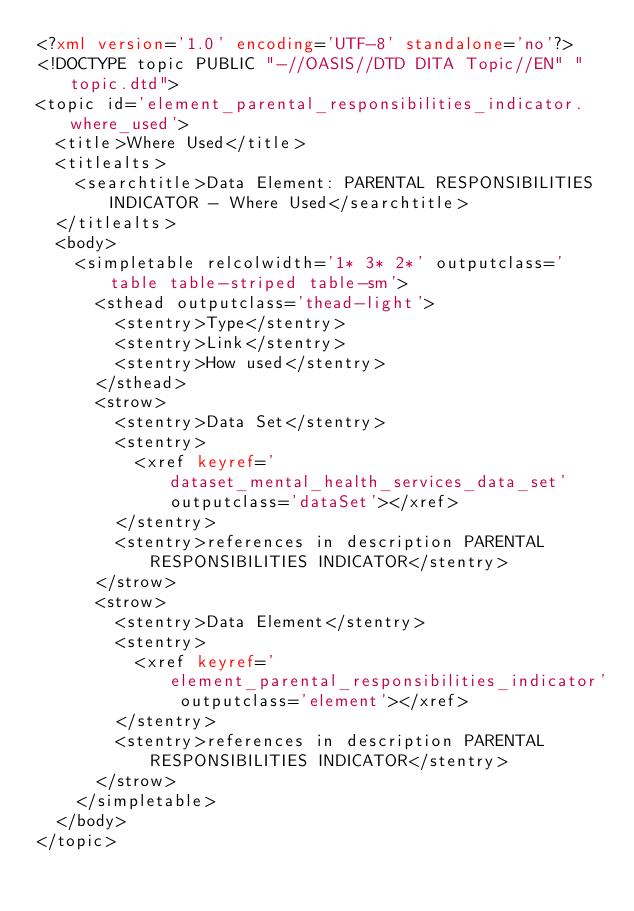Convert code to text. <code><loc_0><loc_0><loc_500><loc_500><_XML_><?xml version='1.0' encoding='UTF-8' standalone='no'?>
<!DOCTYPE topic PUBLIC "-//OASIS//DTD DITA Topic//EN" "topic.dtd">
<topic id='element_parental_responsibilities_indicator.where_used'>
  <title>Where Used</title>
  <titlealts>
    <searchtitle>Data Element: PARENTAL RESPONSIBILITIES INDICATOR - Where Used</searchtitle>
  </titlealts>
  <body>
    <simpletable relcolwidth='1* 3* 2*' outputclass='table table-striped table-sm'>
      <sthead outputclass='thead-light'>
        <stentry>Type</stentry>
        <stentry>Link</stentry>
        <stentry>How used</stentry>
      </sthead>
      <strow>
        <stentry>Data Set</stentry>
        <stentry>
          <xref keyref='dataset_mental_health_services_data_set' outputclass='dataSet'></xref>
        </stentry>
        <stentry>references in description PARENTAL RESPONSIBILITIES INDICATOR</stentry>
      </strow>
      <strow>
        <stentry>Data Element</stentry>
        <stentry>
          <xref keyref='element_parental_responsibilities_indicator' outputclass='element'></xref>
        </stentry>
        <stentry>references in description PARENTAL RESPONSIBILITIES INDICATOR</stentry>
      </strow>
    </simpletable>
  </body>
</topic></code> 